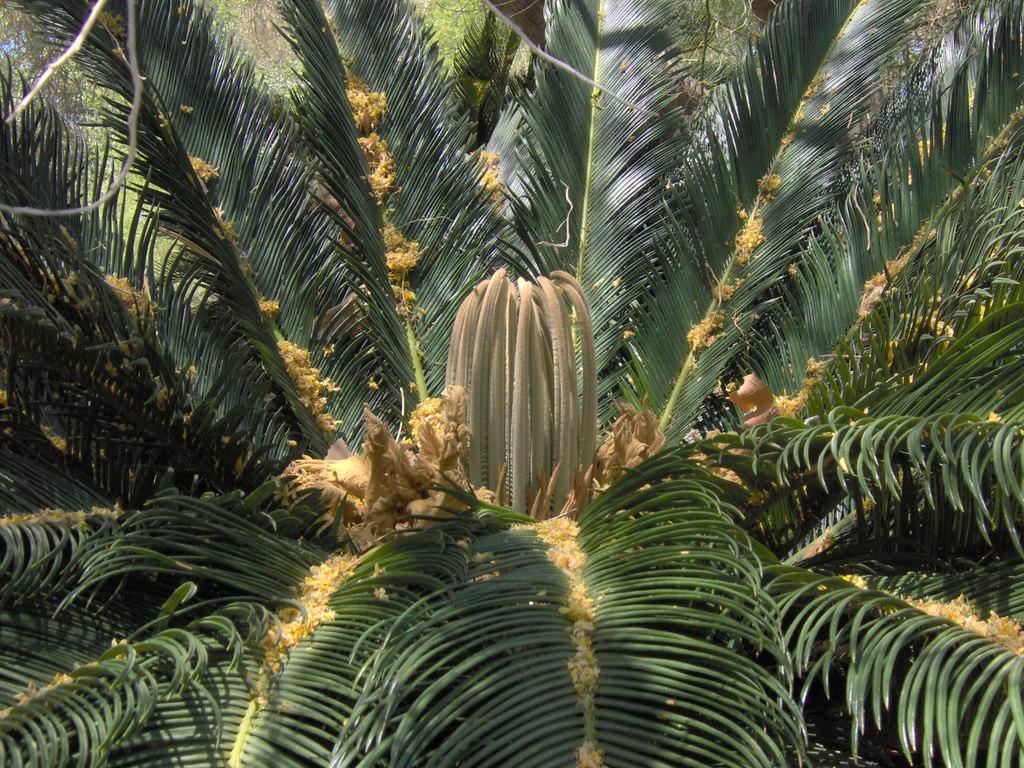What is the main subject in the middle of the image? There is a tree and a cactaceae flower in the middle of the image. Can you describe the tree in the image? Unfortunately, the facts provided do not give any details about the tree. What type of flower is present in the image? The flower present in the image is a cactaceae flower. What type of breakfast is being served under the tree in the image? There is no mention of breakfast or any food items in the image. The image only features a tree and a cactaceae flower. 